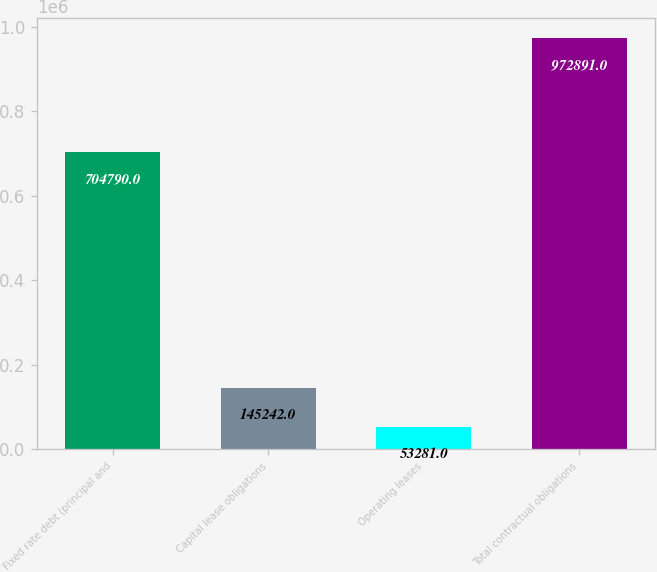Convert chart to OTSL. <chart><loc_0><loc_0><loc_500><loc_500><bar_chart><fcel>Fixed rate debt (principal and<fcel>Capital lease obligations<fcel>Operating leases<fcel>Total contractual obligations<nl><fcel>704790<fcel>145242<fcel>53281<fcel>972891<nl></chart> 